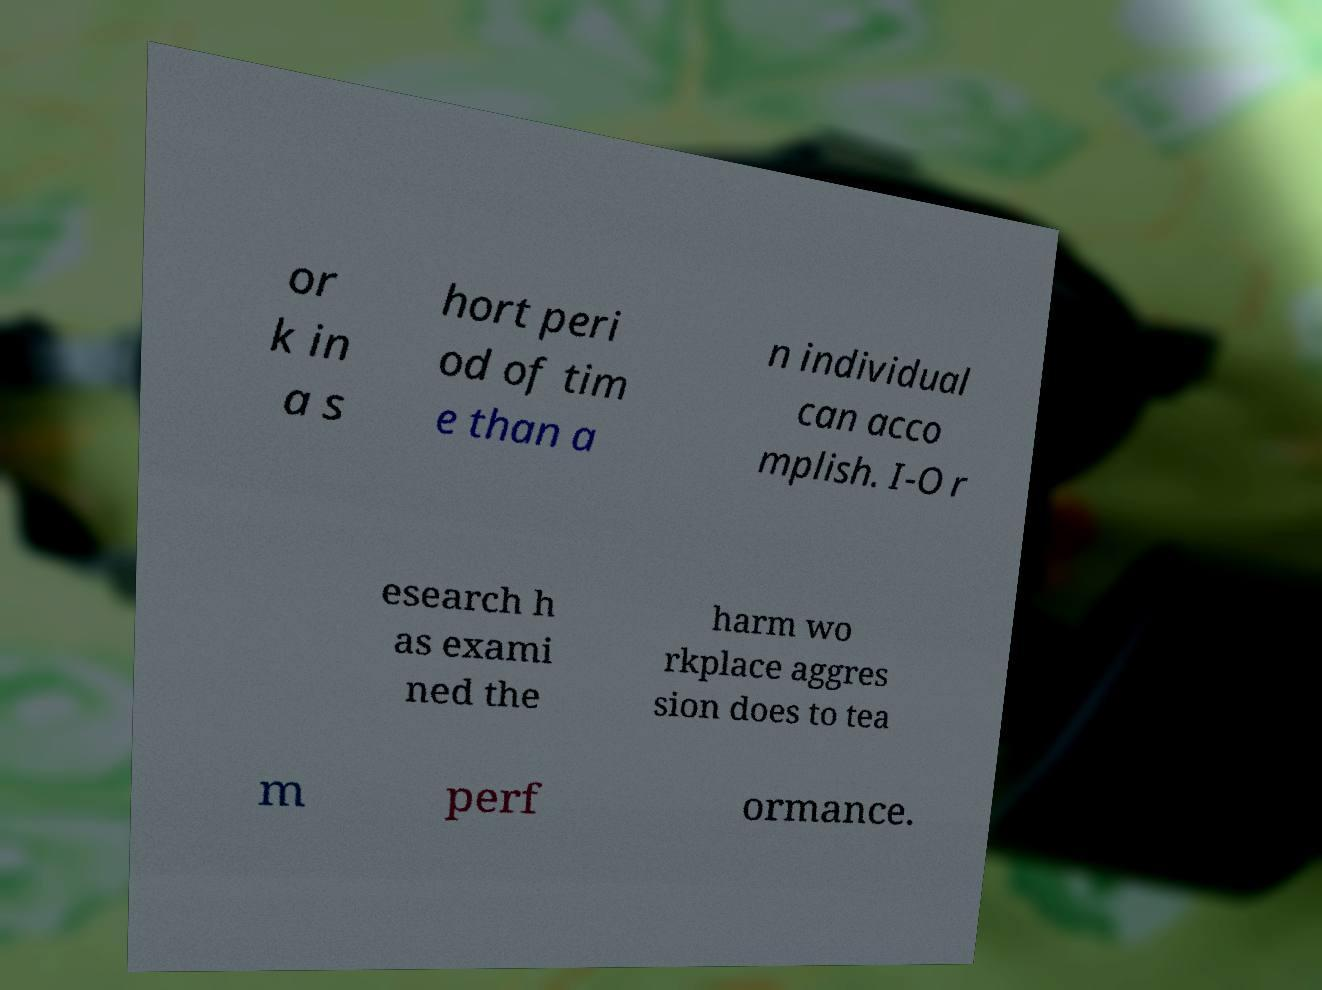I need the written content from this picture converted into text. Can you do that? or k in a s hort peri od of tim e than a n individual can acco mplish. I-O r esearch h as exami ned the harm wo rkplace aggres sion does to tea m perf ormance. 